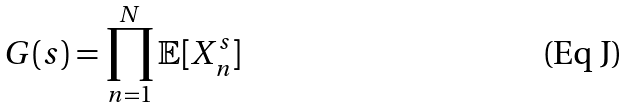Convert formula to latex. <formula><loc_0><loc_0><loc_500><loc_500>G ( s ) = \prod _ { n = 1 } ^ { N } \mathbb { E } [ X _ { n } ^ { s } ]</formula> 